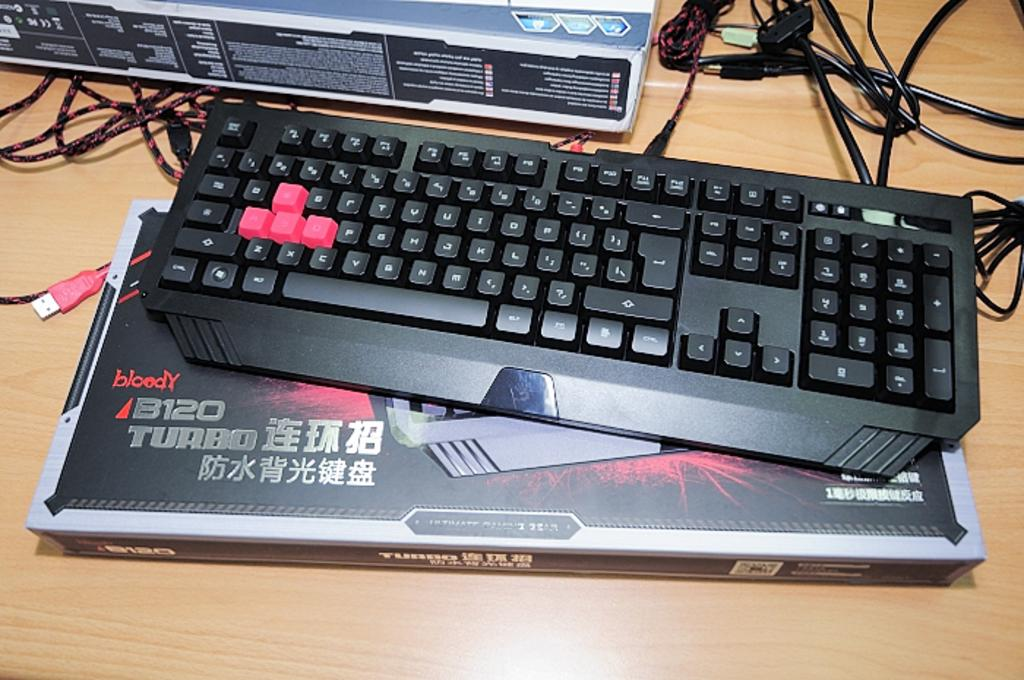Provide a one-sentence caption for the provided image. Keyboard that is chinese with turbo and the box. 